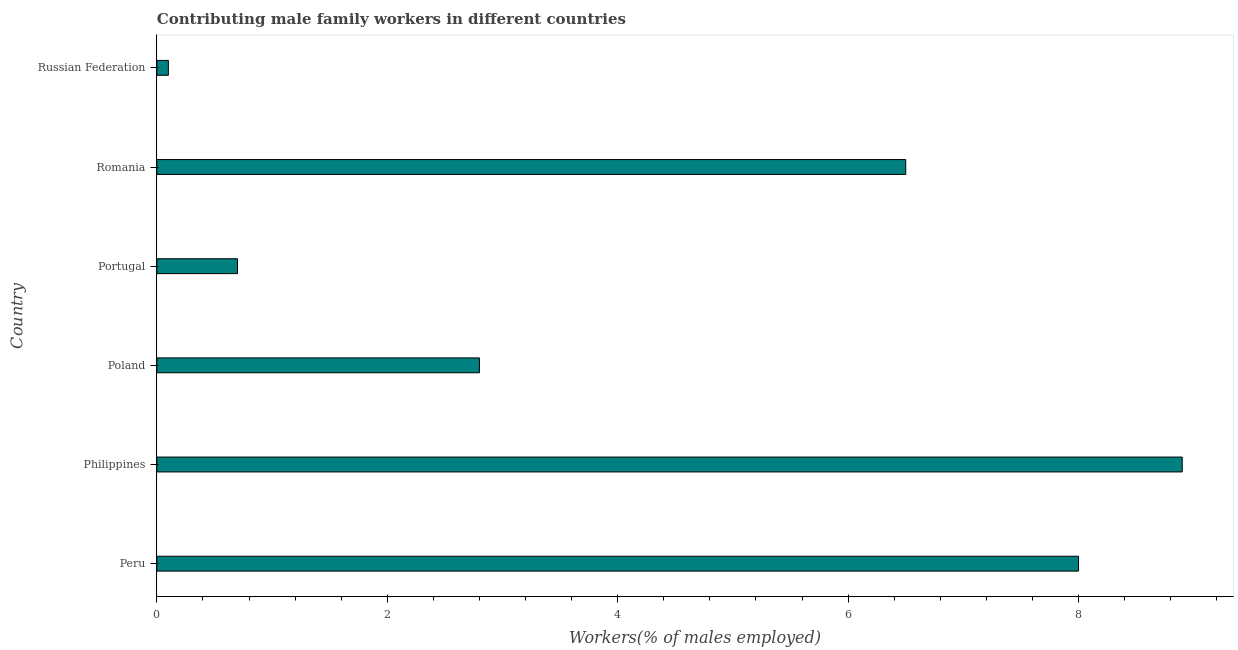Does the graph contain any zero values?
Make the answer very short. No. Does the graph contain grids?
Offer a very short reply. No. What is the title of the graph?
Offer a terse response. Contributing male family workers in different countries. What is the label or title of the X-axis?
Keep it short and to the point. Workers(% of males employed). What is the contributing male family workers in Philippines?
Give a very brief answer. 8.9. Across all countries, what is the maximum contributing male family workers?
Ensure brevity in your answer.  8.9. Across all countries, what is the minimum contributing male family workers?
Your answer should be very brief. 0.1. In which country was the contributing male family workers minimum?
Make the answer very short. Russian Federation. What is the sum of the contributing male family workers?
Your answer should be very brief. 27. What is the difference between the contributing male family workers in Peru and Russian Federation?
Keep it short and to the point. 7.9. What is the average contributing male family workers per country?
Give a very brief answer. 4.5. What is the median contributing male family workers?
Make the answer very short. 4.65. In how many countries, is the contributing male family workers greater than 1.6 %?
Keep it short and to the point. 4. What is the ratio of the contributing male family workers in Portugal to that in Russian Federation?
Offer a very short reply. 7. Is the sum of the contributing male family workers in Peru and Poland greater than the maximum contributing male family workers across all countries?
Offer a terse response. Yes. In how many countries, is the contributing male family workers greater than the average contributing male family workers taken over all countries?
Provide a succinct answer. 3. Are all the bars in the graph horizontal?
Keep it short and to the point. Yes. How many countries are there in the graph?
Your answer should be very brief. 6. Are the values on the major ticks of X-axis written in scientific E-notation?
Offer a terse response. No. What is the Workers(% of males employed) of Peru?
Your answer should be very brief. 8. What is the Workers(% of males employed) of Philippines?
Keep it short and to the point. 8.9. What is the Workers(% of males employed) of Poland?
Give a very brief answer. 2.8. What is the Workers(% of males employed) in Portugal?
Offer a very short reply. 0.7. What is the Workers(% of males employed) in Romania?
Provide a succinct answer. 6.5. What is the Workers(% of males employed) of Russian Federation?
Your answer should be compact. 0.1. What is the difference between the Workers(% of males employed) in Peru and Romania?
Offer a very short reply. 1.5. What is the difference between the Workers(% of males employed) in Peru and Russian Federation?
Provide a short and direct response. 7.9. What is the difference between the Workers(% of males employed) in Philippines and Portugal?
Provide a succinct answer. 8.2. What is the difference between the Workers(% of males employed) in Philippines and Romania?
Offer a very short reply. 2.4. What is the difference between the Workers(% of males employed) in Poland and Portugal?
Offer a very short reply. 2.1. What is the difference between the Workers(% of males employed) in Poland and Russian Federation?
Your answer should be very brief. 2.7. What is the difference between the Workers(% of males employed) in Portugal and Romania?
Make the answer very short. -5.8. What is the difference between the Workers(% of males employed) in Romania and Russian Federation?
Offer a terse response. 6.4. What is the ratio of the Workers(% of males employed) in Peru to that in Philippines?
Offer a very short reply. 0.9. What is the ratio of the Workers(% of males employed) in Peru to that in Poland?
Your response must be concise. 2.86. What is the ratio of the Workers(% of males employed) in Peru to that in Portugal?
Your answer should be very brief. 11.43. What is the ratio of the Workers(% of males employed) in Peru to that in Romania?
Offer a terse response. 1.23. What is the ratio of the Workers(% of males employed) in Peru to that in Russian Federation?
Provide a short and direct response. 80. What is the ratio of the Workers(% of males employed) in Philippines to that in Poland?
Provide a short and direct response. 3.18. What is the ratio of the Workers(% of males employed) in Philippines to that in Portugal?
Provide a short and direct response. 12.71. What is the ratio of the Workers(% of males employed) in Philippines to that in Romania?
Your answer should be very brief. 1.37. What is the ratio of the Workers(% of males employed) in Philippines to that in Russian Federation?
Offer a very short reply. 89. What is the ratio of the Workers(% of males employed) in Poland to that in Portugal?
Give a very brief answer. 4. What is the ratio of the Workers(% of males employed) in Poland to that in Romania?
Ensure brevity in your answer.  0.43. What is the ratio of the Workers(% of males employed) in Poland to that in Russian Federation?
Your answer should be compact. 28. What is the ratio of the Workers(% of males employed) in Portugal to that in Romania?
Offer a very short reply. 0.11. What is the ratio of the Workers(% of males employed) in Portugal to that in Russian Federation?
Ensure brevity in your answer.  7. What is the ratio of the Workers(% of males employed) in Romania to that in Russian Federation?
Make the answer very short. 65. 